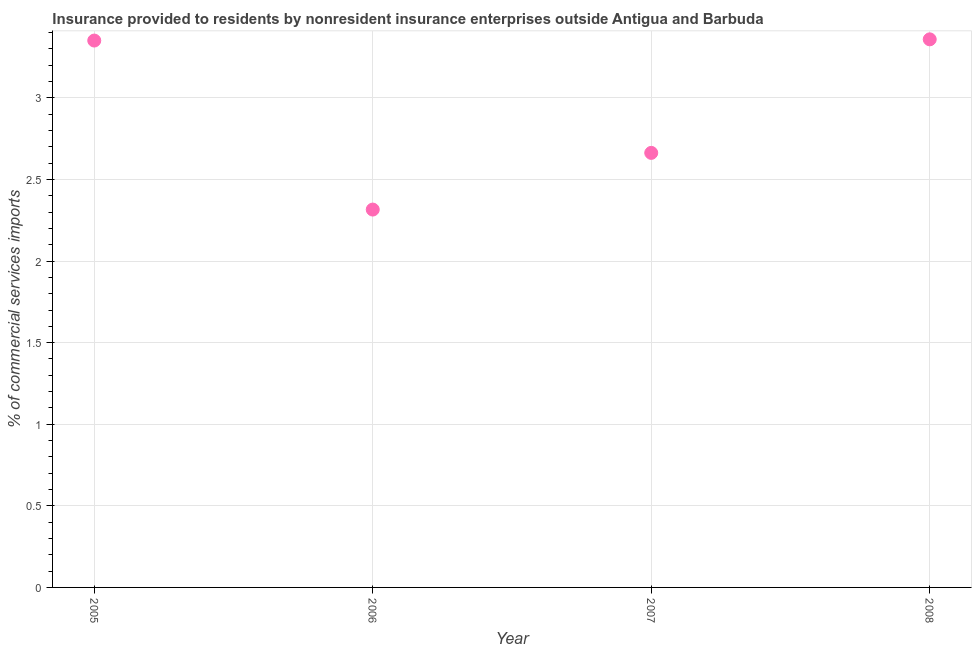What is the insurance provided by non-residents in 2007?
Keep it short and to the point. 2.66. Across all years, what is the maximum insurance provided by non-residents?
Your answer should be very brief. 3.36. Across all years, what is the minimum insurance provided by non-residents?
Provide a succinct answer. 2.32. In which year was the insurance provided by non-residents maximum?
Your response must be concise. 2008. In which year was the insurance provided by non-residents minimum?
Your answer should be compact. 2006. What is the sum of the insurance provided by non-residents?
Ensure brevity in your answer.  11.69. What is the difference between the insurance provided by non-residents in 2006 and 2007?
Your answer should be very brief. -0.35. What is the average insurance provided by non-residents per year?
Offer a terse response. 2.92. What is the median insurance provided by non-residents?
Your response must be concise. 3.01. What is the ratio of the insurance provided by non-residents in 2005 to that in 2008?
Your answer should be compact. 1. Is the difference between the insurance provided by non-residents in 2005 and 2006 greater than the difference between any two years?
Provide a succinct answer. No. What is the difference between the highest and the second highest insurance provided by non-residents?
Give a very brief answer. 0.01. What is the difference between the highest and the lowest insurance provided by non-residents?
Your response must be concise. 1.04. How many dotlines are there?
Keep it short and to the point. 1. How many years are there in the graph?
Give a very brief answer. 4. What is the difference between two consecutive major ticks on the Y-axis?
Provide a short and direct response. 0.5. Does the graph contain grids?
Your answer should be very brief. Yes. What is the title of the graph?
Offer a very short reply. Insurance provided to residents by nonresident insurance enterprises outside Antigua and Barbuda. What is the label or title of the X-axis?
Your answer should be compact. Year. What is the label or title of the Y-axis?
Provide a succinct answer. % of commercial services imports. What is the % of commercial services imports in 2005?
Offer a very short reply. 3.35. What is the % of commercial services imports in 2006?
Ensure brevity in your answer.  2.32. What is the % of commercial services imports in 2007?
Make the answer very short. 2.66. What is the % of commercial services imports in 2008?
Give a very brief answer. 3.36. What is the difference between the % of commercial services imports in 2005 and 2006?
Your answer should be compact. 1.04. What is the difference between the % of commercial services imports in 2005 and 2007?
Offer a very short reply. 0.69. What is the difference between the % of commercial services imports in 2005 and 2008?
Keep it short and to the point. -0.01. What is the difference between the % of commercial services imports in 2006 and 2007?
Your answer should be very brief. -0.35. What is the difference between the % of commercial services imports in 2006 and 2008?
Your response must be concise. -1.04. What is the difference between the % of commercial services imports in 2007 and 2008?
Give a very brief answer. -0.7. What is the ratio of the % of commercial services imports in 2005 to that in 2006?
Give a very brief answer. 1.45. What is the ratio of the % of commercial services imports in 2005 to that in 2007?
Offer a very short reply. 1.26. What is the ratio of the % of commercial services imports in 2005 to that in 2008?
Make the answer very short. 1. What is the ratio of the % of commercial services imports in 2006 to that in 2007?
Offer a terse response. 0.87. What is the ratio of the % of commercial services imports in 2006 to that in 2008?
Provide a short and direct response. 0.69. What is the ratio of the % of commercial services imports in 2007 to that in 2008?
Your answer should be very brief. 0.79. 